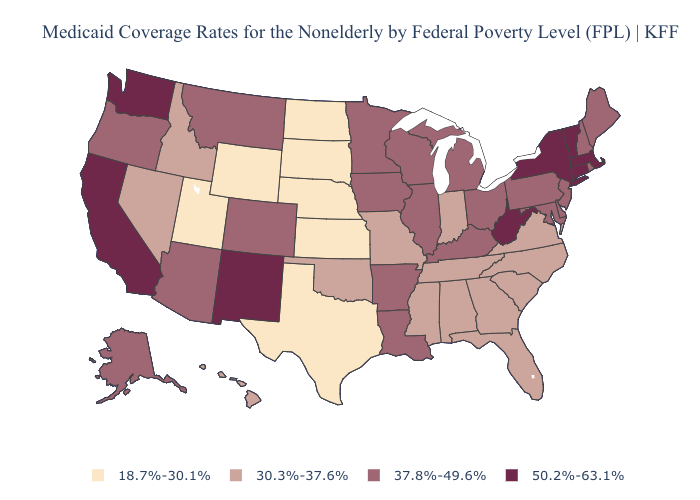How many symbols are there in the legend?
Write a very short answer. 4. What is the highest value in the USA?
Concise answer only. 50.2%-63.1%. What is the lowest value in states that border Illinois?
Be succinct. 30.3%-37.6%. Does North Dakota have the lowest value in the USA?
Short answer required. Yes. What is the value of Delaware?
Keep it brief. 37.8%-49.6%. Does New Mexico have the lowest value in the USA?
Keep it brief. No. How many symbols are there in the legend?
Short answer required. 4. Is the legend a continuous bar?
Answer briefly. No. What is the highest value in states that border Wyoming?
Be succinct. 37.8%-49.6%. Among the states that border Montana , which have the highest value?
Short answer required. Idaho. Name the states that have a value in the range 18.7%-30.1%?
Short answer required. Kansas, Nebraska, North Dakota, South Dakota, Texas, Utah, Wyoming. What is the value of Rhode Island?
Short answer required. 37.8%-49.6%. Name the states that have a value in the range 37.8%-49.6%?
Write a very short answer. Alaska, Arizona, Arkansas, Colorado, Delaware, Illinois, Iowa, Kentucky, Louisiana, Maine, Maryland, Michigan, Minnesota, Montana, New Hampshire, New Jersey, Ohio, Oregon, Pennsylvania, Rhode Island, Wisconsin. 